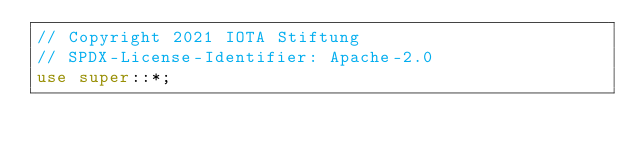<code> <loc_0><loc_0><loc_500><loc_500><_Rust_>// Copyright 2021 IOTA Stiftung
// SPDX-License-Identifier: Apache-2.0
use super::*;
</code> 